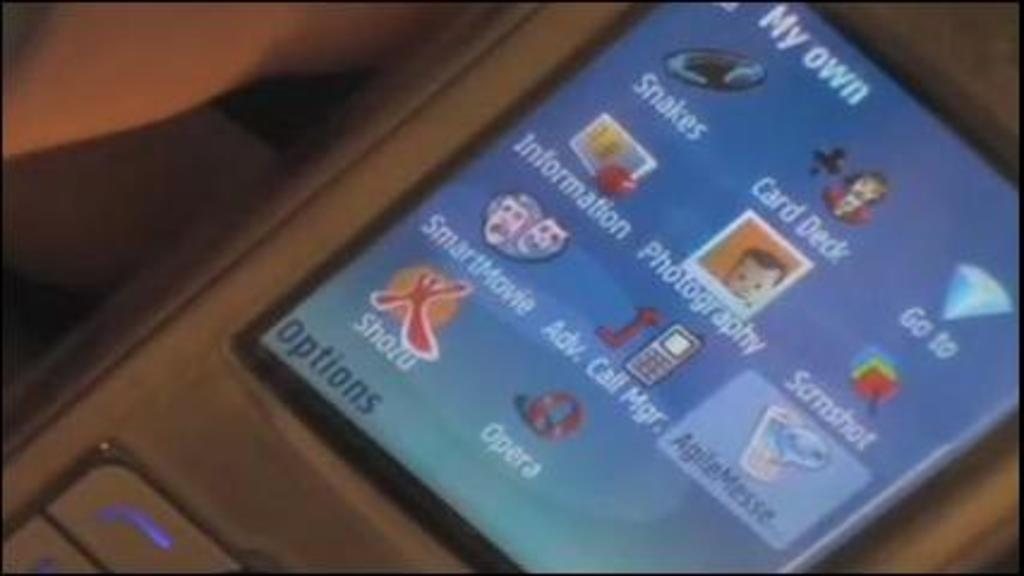Provide a one-sentence caption for the provided image. An old phone with My Own written at the top is being held in a hand. 